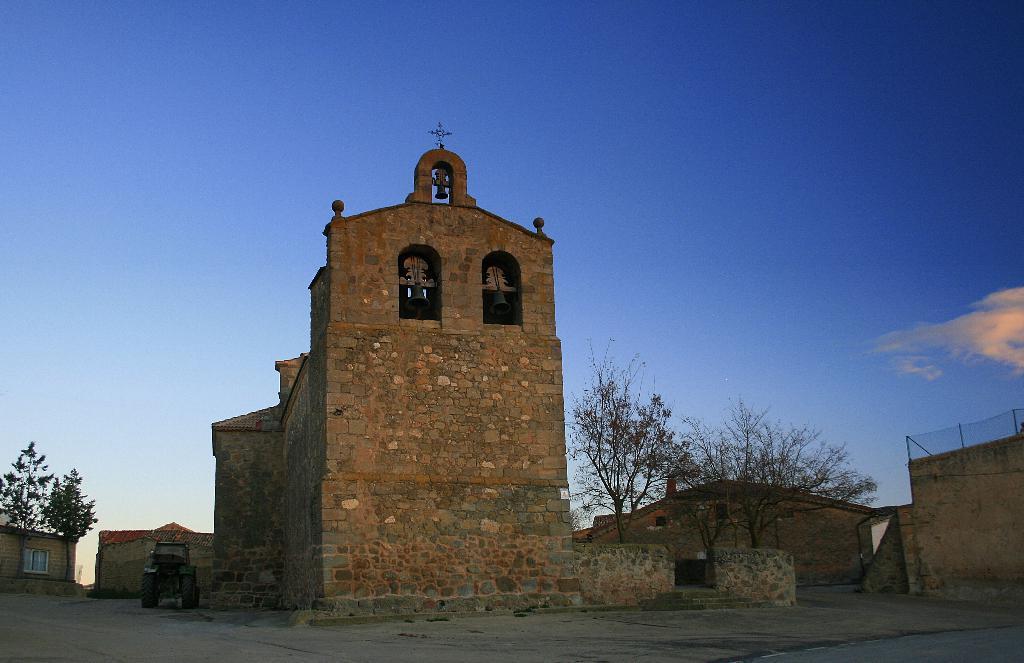Could you give a brief overview of what you see in this image? In this picture I can see there are few buildings and it has bells and there is a window in the building at the left backdrop and there are few trees and the sky is clear. 